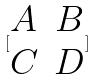Convert formula to latex. <formula><loc_0><loc_0><loc_500><loc_500>[ \begin{matrix} A & B \\ C & D \end{matrix} ]</formula> 